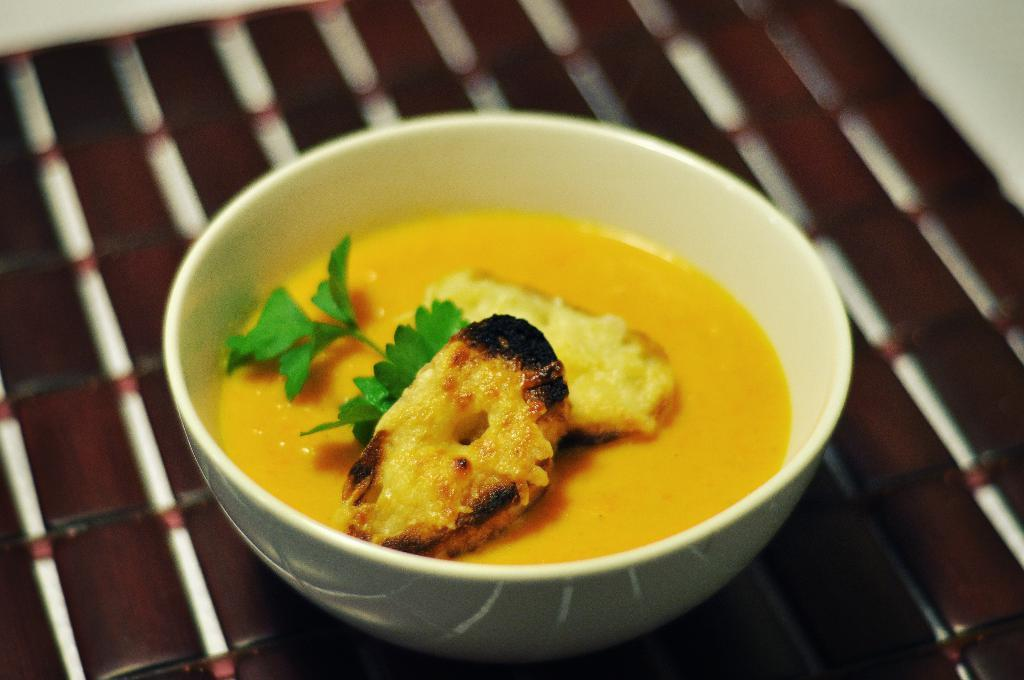What is in the bowl that is visible in the image? There is a white bowl with food in the image. Where is the bowl located in the image? The bowl is on a surface that resembles a table. Can you describe any other objects in the image? There are two white objects in the top left and right side corners of the image. Are there any lizards crawling on the table in the image? There is no indication of lizards or any other animals in the image; it only shows a white bowl with food on a table-like surface and two white objects in the corners. 